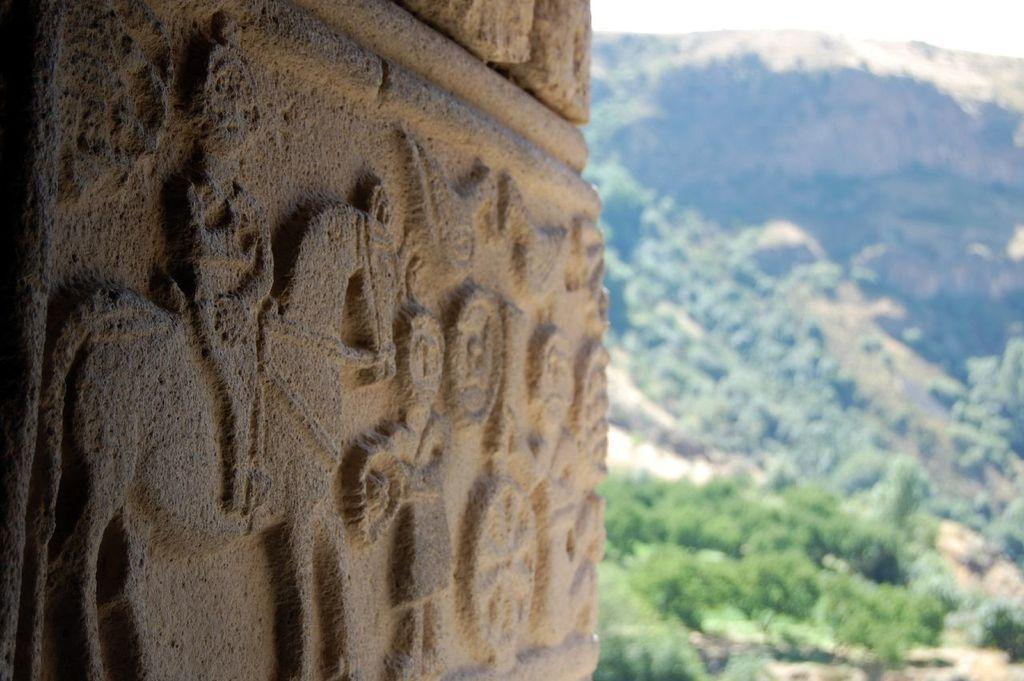What type of artwork is featured in the image? There is a stone carving in the image. What type of natural environment is depicted in the image? There are trees and mountains in the image. What can be seen in the background of the image? The sky is visible in the background of the image. How many snails can be seen crawling on the stone carving in the image? There are no snails present in the image; it features a stone carving, trees, mountains, and the sky. What type of meal is the cook preparing in the image? There is no cook or meal preparation present in the image. 